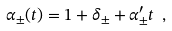<formula> <loc_0><loc_0><loc_500><loc_500>\alpha _ { \pm } ( t ) = 1 + \delta _ { \pm } + \alpha ^ { \prime } _ { \pm } t \ ,</formula> 